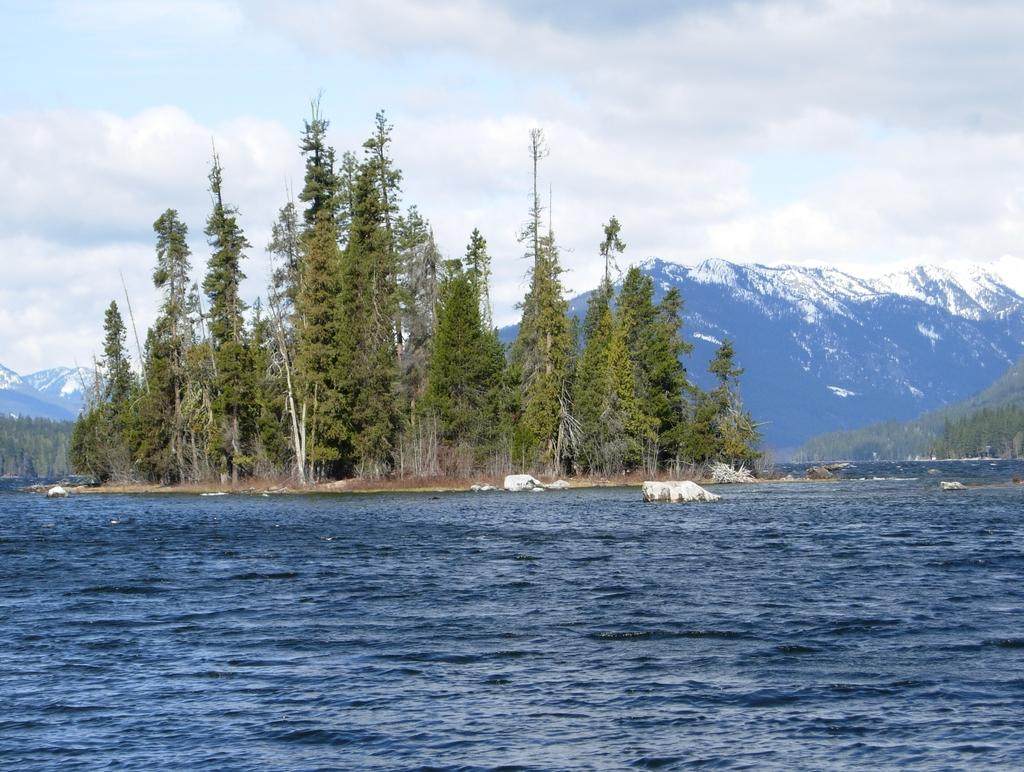What is the primary element in the image? There is water in the image. What other objects or features can be seen in the image? There are stones, trees, and mountains visible in the image. What is visible in the background of the image? The sky is visible in the background of the image. Can you see a rose floating on the water in the image? There is no rose present in the image. Is there an airplane flying over the mountains in the image? There is no airplane visible in the image. 